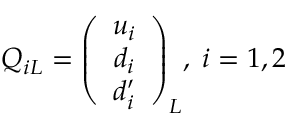<formula> <loc_0><loc_0><loc_500><loc_500>Q _ { i L } = \left ( \begin{array} { c } { { u _ { i } } } \\ { { d _ { i } } } \\ { { d _ { i } ^ { \prime } } } \end{array} \right ) _ { L } \, , \, i = 1 , 2</formula> 